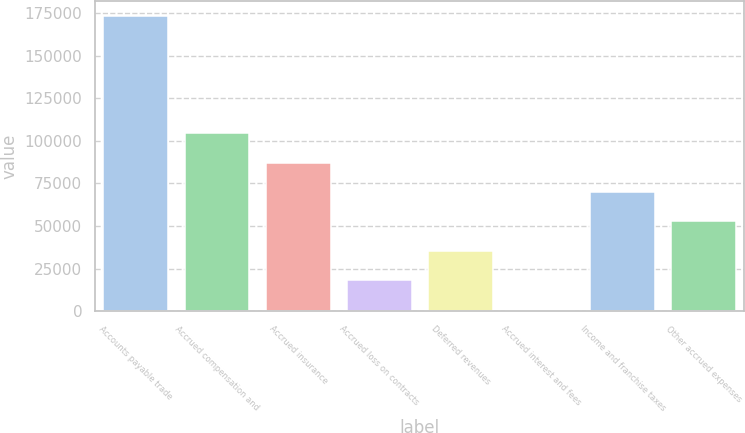<chart> <loc_0><loc_0><loc_500><loc_500><bar_chart><fcel>Accounts payable trade<fcel>Accrued compensation and<fcel>Accrued insurance<fcel>Accrued loss on contracts<fcel>Deferred revenues<fcel>Accrued interest and fees<fcel>Income and franchise taxes<fcel>Other accrued expenses<nl><fcel>173301<fcel>104391<fcel>87163.5<fcel>18253.5<fcel>35481<fcel>1026<fcel>69936<fcel>52708.5<nl></chart> 